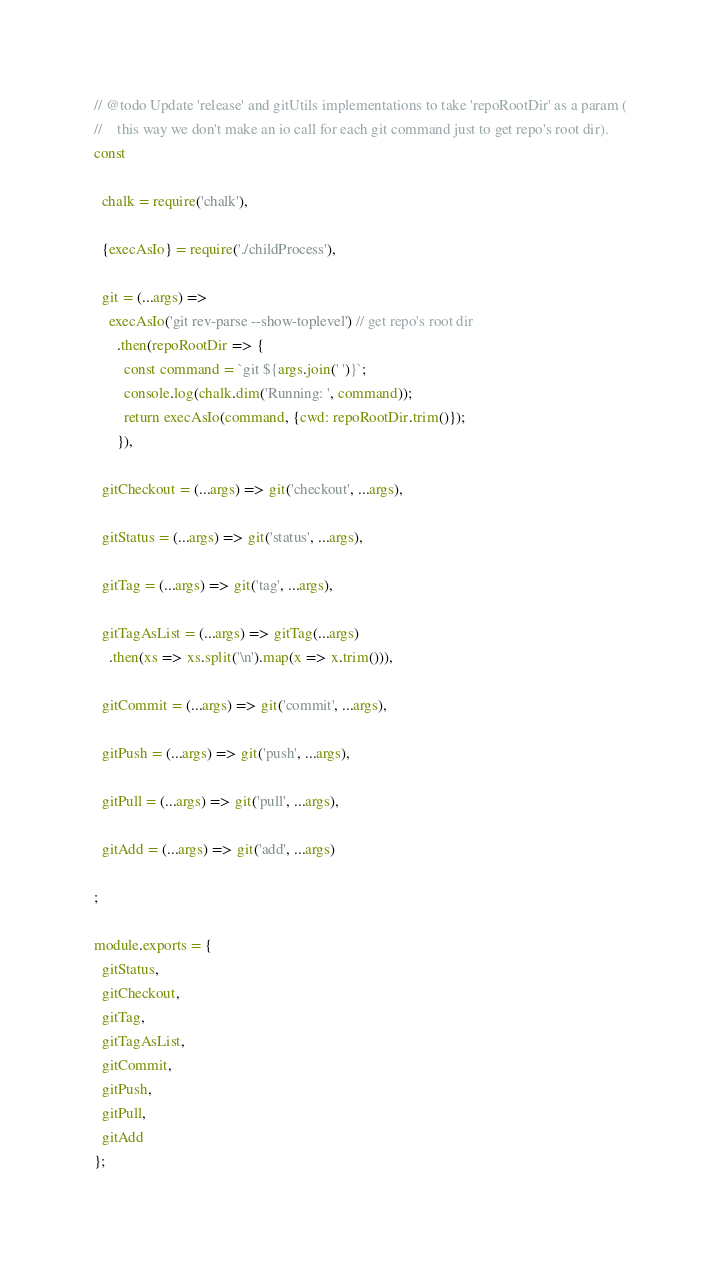<code> <loc_0><loc_0><loc_500><loc_500><_JavaScript_>// @todo Update 'release' and gitUtils implementations to take 'repoRootDir' as a param (
//    this way we don't make an io call for each git command just to get repo's root dir).
const

  chalk = require('chalk'),

  {execAsIo} = require('./childProcess'),

  git = (...args) =>
    execAsIo('git rev-parse --show-toplevel') // get repo's root dir
      .then(repoRootDir => {
        const command = `git ${args.join(' ')}`;
        console.log(chalk.dim('Running: ', command));
        return execAsIo(command, {cwd: repoRootDir.trim()});
      }),

  gitCheckout = (...args) => git('checkout', ...args),

  gitStatus = (...args) => git('status', ...args),

  gitTag = (...args) => git('tag', ...args),

  gitTagAsList = (...args) => gitTag(...args)
    .then(xs => xs.split('\n').map(x => x.trim())),

  gitCommit = (...args) => git('commit', ...args),

  gitPush = (...args) => git('push', ...args),

  gitPull = (...args) => git('pull', ...args),

  gitAdd = (...args) => git('add', ...args)

;

module.exports = {
  gitStatus,
  gitCheckout,
  gitTag,
  gitTagAsList,
  gitCommit,
  gitPush,
  gitPull,
  gitAdd
};
</code> 